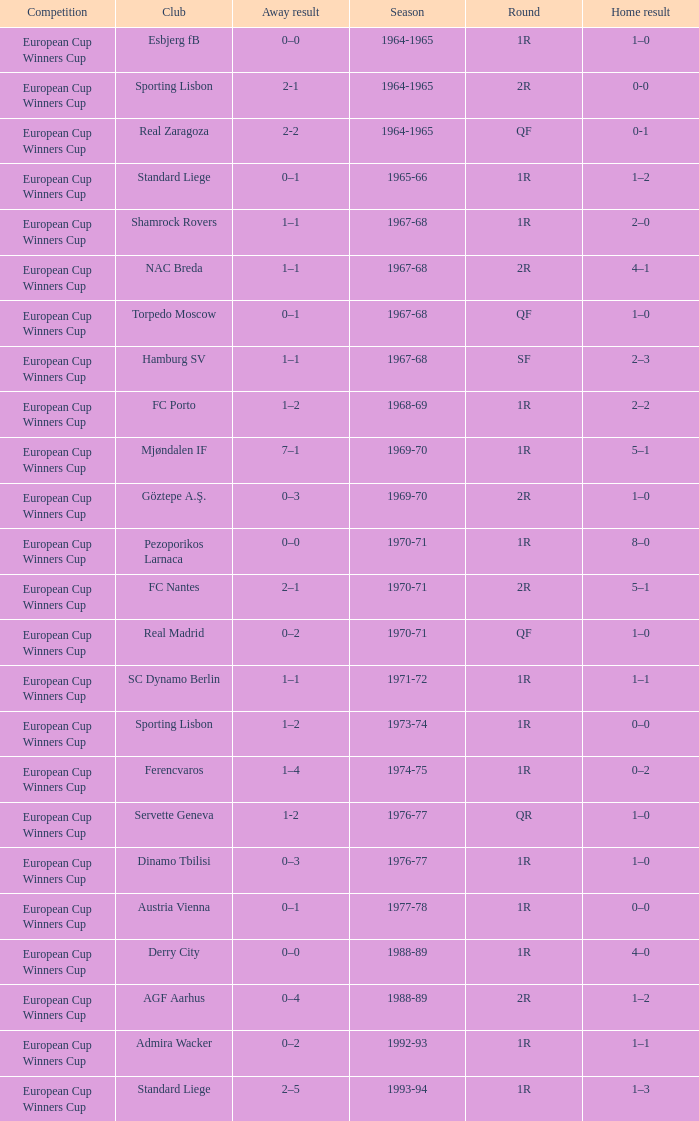Away result of 1–1, and a Round of 1r, and a Season of 1967-68 involves what club? Shamrock Rovers. 